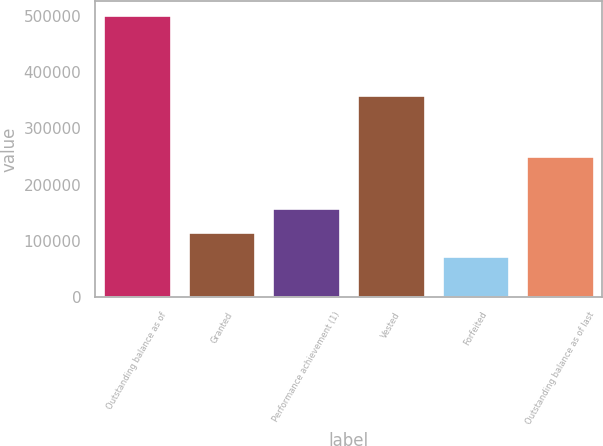Convert chart to OTSL. <chart><loc_0><loc_0><loc_500><loc_500><bar_chart><fcel>Outstanding balance as of<fcel>Granted<fcel>Performance achievement (1)<fcel>Vested<fcel>Forfeited<fcel>Outstanding balance as of last<nl><fcel>501261<fcel>115514<fcel>158375<fcel>359370<fcel>72653<fcel>250333<nl></chart> 